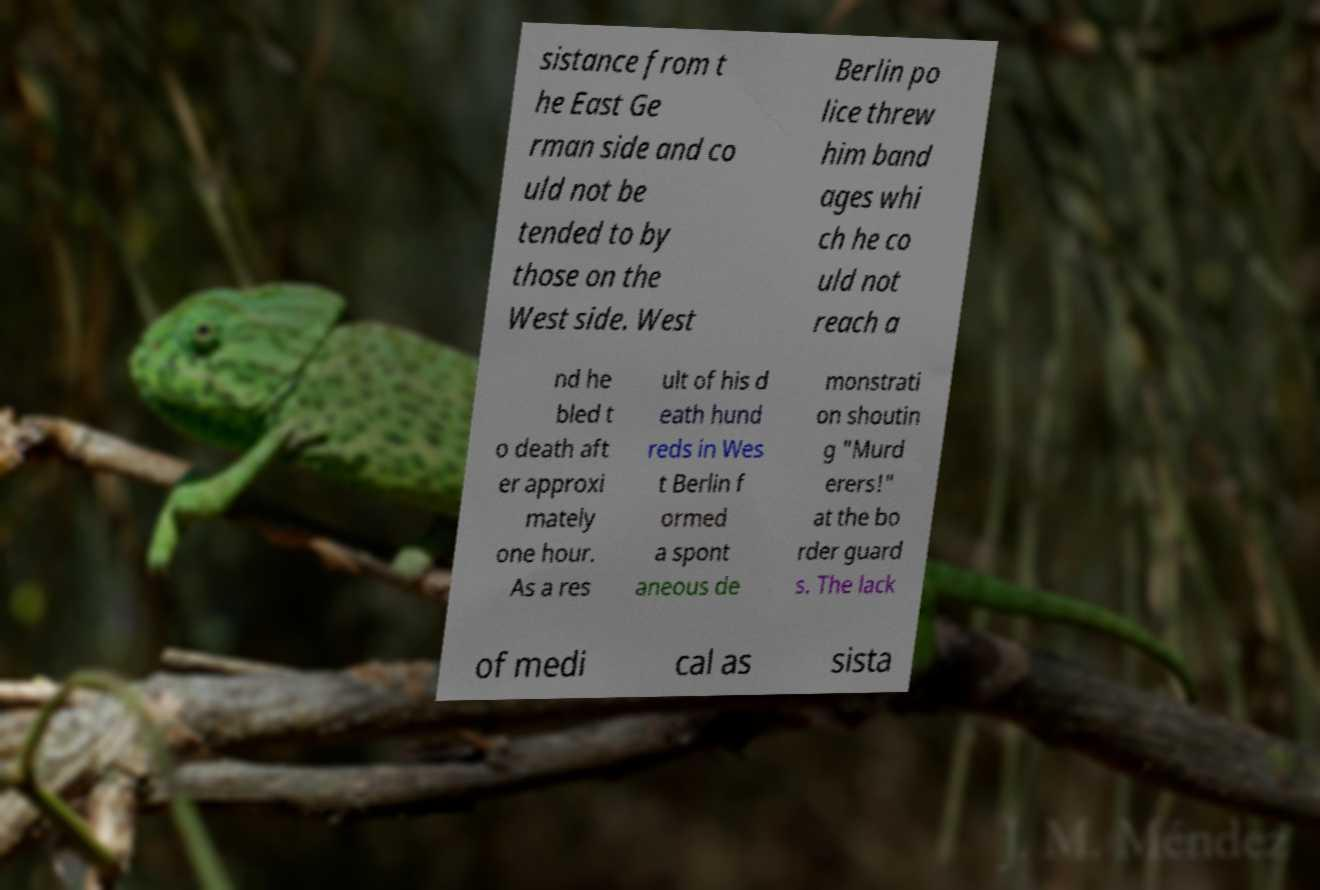Please read and relay the text visible in this image. What does it say? sistance from t he East Ge rman side and co uld not be tended to by those on the West side. West Berlin po lice threw him band ages whi ch he co uld not reach a nd he bled t o death aft er approxi mately one hour. As a res ult of his d eath hund reds in Wes t Berlin f ormed a spont aneous de monstrati on shoutin g "Murd erers!" at the bo rder guard s. The lack of medi cal as sista 